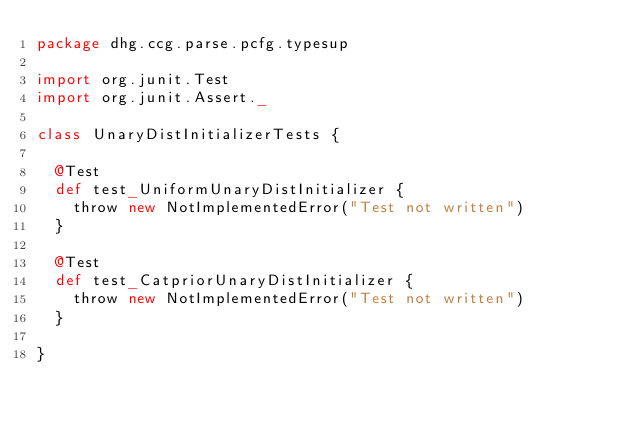<code> <loc_0><loc_0><loc_500><loc_500><_Scala_>package dhg.ccg.parse.pcfg.typesup

import org.junit.Test
import org.junit.Assert._

class UnaryDistInitializerTests {
  
  @Test
  def test_UniformUnaryDistInitializer {
    throw new NotImplementedError("Test not written")
  }

  @Test
  def test_CatpriorUnaryDistInitializer {
    throw new NotImplementedError("Test not written")
  }

}
</code> 